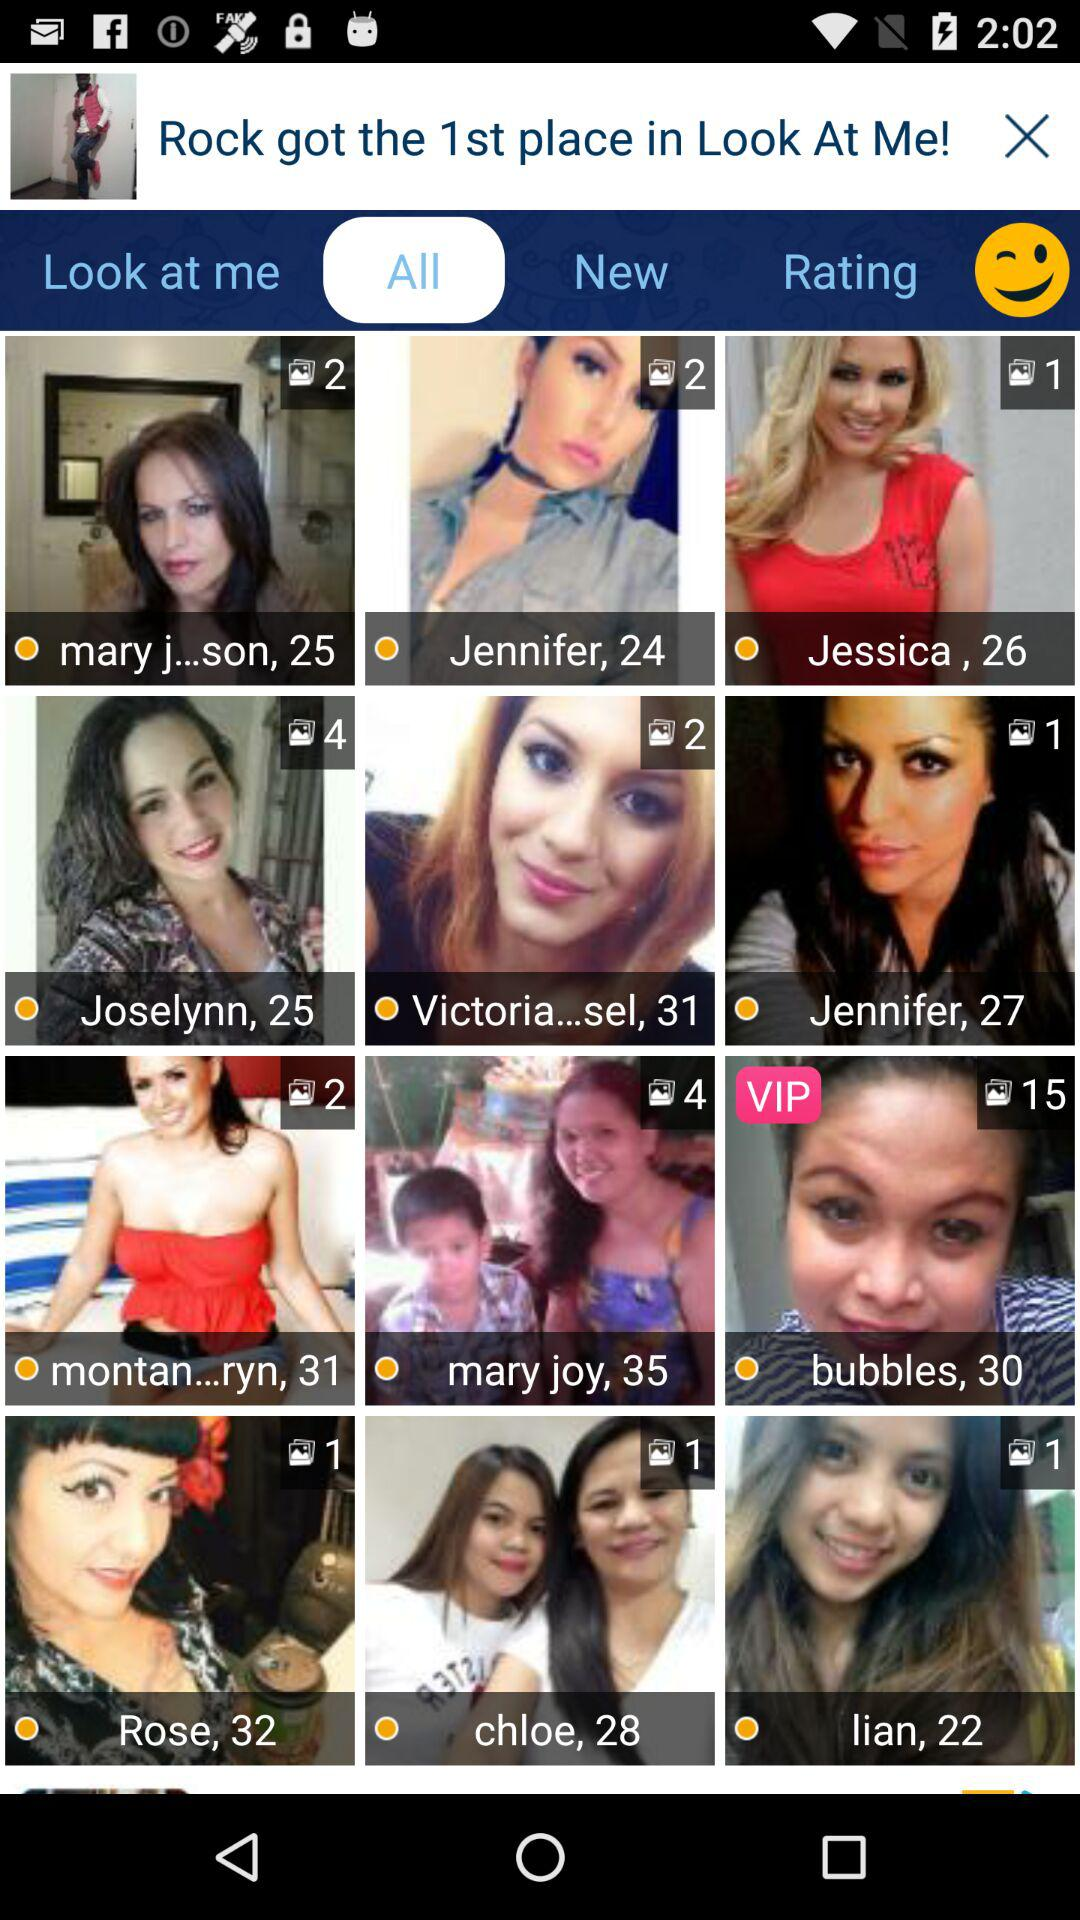How many photos are there of Chloe? There is 1 photo of Chloe. 